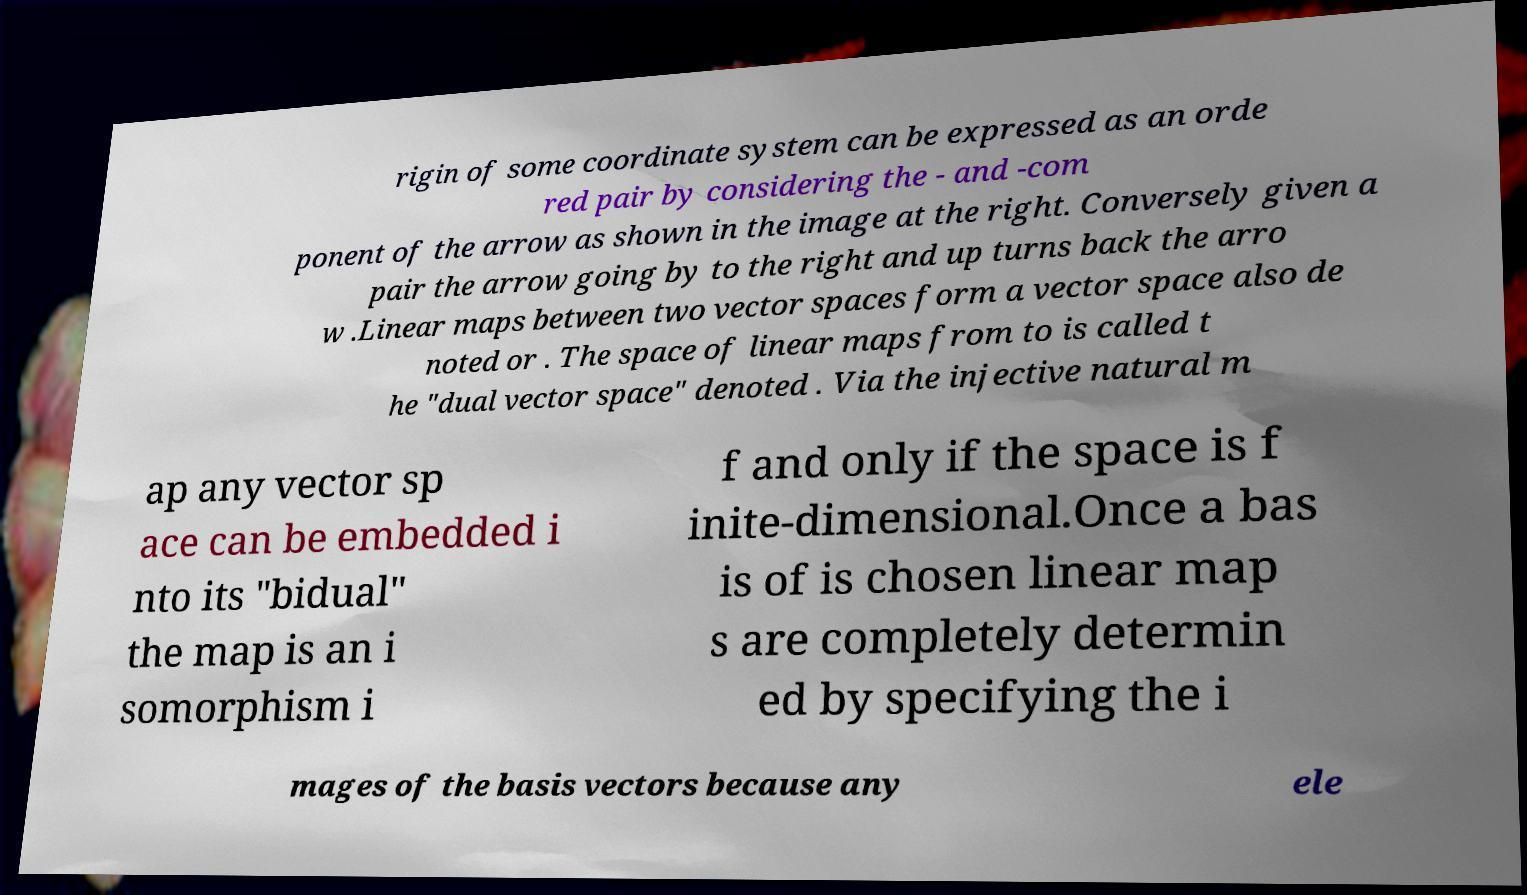What messages or text are displayed in this image? I need them in a readable, typed format. rigin of some coordinate system can be expressed as an orde red pair by considering the - and -com ponent of the arrow as shown in the image at the right. Conversely given a pair the arrow going by to the right and up turns back the arro w .Linear maps between two vector spaces form a vector space also de noted or . The space of linear maps from to is called t he "dual vector space" denoted . Via the injective natural m ap any vector sp ace can be embedded i nto its "bidual" the map is an i somorphism i f and only if the space is f inite-dimensional.Once a bas is of is chosen linear map s are completely determin ed by specifying the i mages of the basis vectors because any ele 